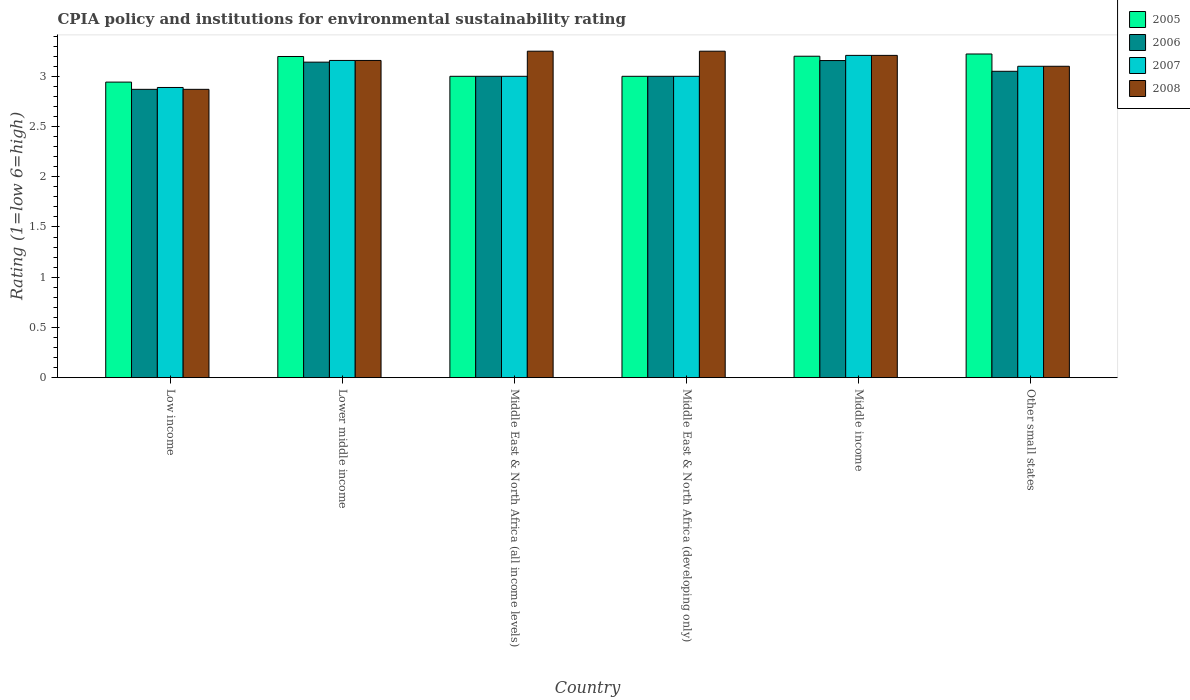Are the number of bars on each tick of the X-axis equal?
Make the answer very short. Yes. What is the label of the 4th group of bars from the left?
Ensure brevity in your answer.  Middle East & North Africa (developing only). What is the CPIA rating in 2006 in Middle income?
Keep it short and to the point. 3.16. Across all countries, what is the maximum CPIA rating in 2005?
Ensure brevity in your answer.  3.22. Across all countries, what is the minimum CPIA rating in 2007?
Offer a very short reply. 2.89. In which country was the CPIA rating in 2008 maximum?
Offer a very short reply. Middle East & North Africa (all income levels). In which country was the CPIA rating in 2006 minimum?
Give a very brief answer. Low income. What is the total CPIA rating in 2006 in the graph?
Ensure brevity in your answer.  18.22. What is the difference between the CPIA rating in 2006 in Lower middle income and that in Middle income?
Make the answer very short. -0.02. What is the difference between the CPIA rating in 2008 in Middle East & North Africa (developing only) and the CPIA rating in 2005 in Middle East & North Africa (all income levels)?
Offer a terse response. 0.25. What is the average CPIA rating in 2006 per country?
Your answer should be compact. 3.04. In how many countries, is the CPIA rating in 2007 greater than 1?
Give a very brief answer. 6. What is the ratio of the CPIA rating in 2006 in Middle East & North Africa (developing only) to that in Middle income?
Provide a short and direct response. 0.95. What is the difference between the highest and the second highest CPIA rating in 2008?
Ensure brevity in your answer.  -0.04. What is the difference between the highest and the lowest CPIA rating in 2005?
Make the answer very short. 0.28. In how many countries, is the CPIA rating in 2007 greater than the average CPIA rating in 2007 taken over all countries?
Offer a very short reply. 3. Is the sum of the CPIA rating in 2006 in Lower middle income and Middle income greater than the maximum CPIA rating in 2008 across all countries?
Offer a very short reply. Yes. What does the 1st bar from the left in Low income represents?
Offer a very short reply. 2005. How many bars are there?
Keep it short and to the point. 24. Are all the bars in the graph horizontal?
Your answer should be compact. No. How many countries are there in the graph?
Your answer should be compact. 6. What is the difference between two consecutive major ticks on the Y-axis?
Ensure brevity in your answer.  0.5. Does the graph contain grids?
Your response must be concise. No. What is the title of the graph?
Ensure brevity in your answer.  CPIA policy and institutions for environmental sustainability rating. What is the label or title of the Y-axis?
Make the answer very short. Rating (1=low 6=high). What is the Rating (1=low 6=high) of 2005 in Low income?
Provide a short and direct response. 2.94. What is the Rating (1=low 6=high) in 2006 in Low income?
Offer a very short reply. 2.87. What is the Rating (1=low 6=high) in 2007 in Low income?
Provide a succinct answer. 2.89. What is the Rating (1=low 6=high) of 2008 in Low income?
Provide a succinct answer. 2.87. What is the Rating (1=low 6=high) in 2005 in Lower middle income?
Your answer should be very brief. 3.2. What is the Rating (1=low 6=high) of 2006 in Lower middle income?
Your response must be concise. 3.14. What is the Rating (1=low 6=high) in 2007 in Lower middle income?
Make the answer very short. 3.16. What is the Rating (1=low 6=high) of 2008 in Lower middle income?
Your response must be concise. 3.16. What is the Rating (1=low 6=high) of 2007 in Middle East & North Africa (all income levels)?
Ensure brevity in your answer.  3. What is the Rating (1=low 6=high) in 2008 in Middle East & North Africa (all income levels)?
Provide a short and direct response. 3.25. What is the Rating (1=low 6=high) in 2005 in Middle East & North Africa (developing only)?
Offer a very short reply. 3. What is the Rating (1=low 6=high) in 2007 in Middle East & North Africa (developing only)?
Your response must be concise. 3. What is the Rating (1=low 6=high) in 2008 in Middle East & North Africa (developing only)?
Ensure brevity in your answer.  3.25. What is the Rating (1=low 6=high) of 2005 in Middle income?
Your answer should be very brief. 3.2. What is the Rating (1=low 6=high) in 2006 in Middle income?
Your response must be concise. 3.16. What is the Rating (1=low 6=high) in 2007 in Middle income?
Offer a very short reply. 3.21. What is the Rating (1=low 6=high) in 2008 in Middle income?
Provide a succinct answer. 3.21. What is the Rating (1=low 6=high) of 2005 in Other small states?
Make the answer very short. 3.22. What is the Rating (1=low 6=high) in 2006 in Other small states?
Make the answer very short. 3.05. What is the Rating (1=low 6=high) of 2008 in Other small states?
Make the answer very short. 3.1. Across all countries, what is the maximum Rating (1=low 6=high) of 2005?
Your response must be concise. 3.22. Across all countries, what is the maximum Rating (1=low 6=high) of 2006?
Your answer should be compact. 3.16. Across all countries, what is the maximum Rating (1=low 6=high) of 2007?
Your answer should be compact. 3.21. Across all countries, what is the maximum Rating (1=low 6=high) in 2008?
Provide a short and direct response. 3.25. Across all countries, what is the minimum Rating (1=low 6=high) in 2005?
Your answer should be very brief. 2.94. Across all countries, what is the minimum Rating (1=low 6=high) in 2006?
Your response must be concise. 2.87. Across all countries, what is the minimum Rating (1=low 6=high) in 2007?
Offer a very short reply. 2.89. Across all countries, what is the minimum Rating (1=low 6=high) in 2008?
Your response must be concise. 2.87. What is the total Rating (1=low 6=high) of 2005 in the graph?
Offer a terse response. 18.56. What is the total Rating (1=low 6=high) of 2006 in the graph?
Give a very brief answer. 18.22. What is the total Rating (1=low 6=high) in 2007 in the graph?
Keep it short and to the point. 18.36. What is the total Rating (1=low 6=high) of 2008 in the graph?
Your answer should be very brief. 18.84. What is the difference between the Rating (1=low 6=high) in 2005 in Low income and that in Lower middle income?
Your answer should be very brief. -0.26. What is the difference between the Rating (1=low 6=high) of 2006 in Low income and that in Lower middle income?
Keep it short and to the point. -0.27. What is the difference between the Rating (1=low 6=high) in 2007 in Low income and that in Lower middle income?
Offer a terse response. -0.27. What is the difference between the Rating (1=low 6=high) in 2008 in Low income and that in Lower middle income?
Your response must be concise. -0.29. What is the difference between the Rating (1=low 6=high) of 2005 in Low income and that in Middle East & North Africa (all income levels)?
Offer a very short reply. -0.06. What is the difference between the Rating (1=low 6=high) of 2006 in Low income and that in Middle East & North Africa (all income levels)?
Provide a short and direct response. -0.13. What is the difference between the Rating (1=low 6=high) of 2007 in Low income and that in Middle East & North Africa (all income levels)?
Offer a terse response. -0.11. What is the difference between the Rating (1=low 6=high) of 2008 in Low income and that in Middle East & North Africa (all income levels)?
Offer a very short reply. -0.38. What is the difference between the Rating (1=low 6=high) in 2005 in Low income and that in Middle East & North Africa (developing only)?
Ensure brevity in your answer.  -0.06. What is the difference between the Rating (1=low 6=high) in 2006 in Low income and that in Middle East & North Africa (developing only)?
Offer a very short reply. -0.13. What is the difference between the Rating (1=low 6=high) of 2007 in Low income and that in Middle East & North Africa (developing only)?
Offer a very short reply. -0.11. What is the difference between the Rating (1=low 6=high) of 2008 in Low income and that in Middle East & North Africa (developing only)?
Provide a short and direct response. -0.38. What is the difference between the Rating (1=low 6=high) in 2005 in Low income and that in Middle income?
Offer a very short reply. -0.26. What is the difference between the Rating (1=low 6=high) in 2006 in Low income and that in Middle income?
Offer a terse response. -0.29. What is the difference between the Rating (1=low 6=high) in 2007 in Low income and that in Middle income?
Offer a terse response. -0.32. What is the difference between the Rating (1=low 6=high) in 2008 in Low income and that in Middle income?
Offer a very short reply. -0.34. What is the difference between the Rating (1=low 6=high) in 2005 in Low income and that in Other small states?
Offer a very short reply. -0.28. What is the difference between the Rating (1=low 6=high) in 2006 in Low income and that in Other small states?
Give a very brief answer. -0.18. What is the difference between the Rating (1=low 6=high) of 2007 in Low income and that in Other small states?
Your answer should be compact. -0.21. What is the difference between the Rating (1=low 6=high) in 2008 in Low income and that in Other small states?
Your answer should be compact. -0.23. What is the difference between the Rating (1=low 6=high) in 2005 in Lower middle income and that in Middle East & North Africa (all income levels)?
Keep it short and to the point. 0.2. What is the difference between the Rating (1=low 6=high) in 2006 in Lower middle income and that in Middle East & North Africa (all income levels)?
Provide a short and direct response. 0.14. What is the difference between the Rating (1=low 6=high) in 2007 in Lower middle income and that in Middle East & North Africa (all income levels)?
Your answer should be very brief. 0.16. What is the difference between the Rating (1=low 6=high) in 2008 in Lower middle income and that in Middle East & North Africa (all income levels)?
Your answer should be very brief. -0.09. What is the difference between the Rating (1=low 6=high) of 2005 in Lower middle income and that in Middle East & North Africa (developing only)?
Your response must be concise. 0.2. What is the difference between the Rating (1=low 6=high) of 2006 in Lower middle income and that in Middle East & North Africa (developing only)?
Give a very brief answer. 0.14. What is the difference between the Rating (1=low 6=high) of 2007 in Lower middle income and that in Middle East & North Africa (developing only)?
Offer a terse response. 0.16. What is the difference between the Rating (1=low 6=high) of 2008 in Lower middle income and that in Middle East & North Africa (developing only)?
Offer a very short reply. -0.09. What is the difference between the Rating (1=low 6=high) of 2005 in Lower middle income and that in Middle income?
Offer a terse response. -0. What is the difference between the Rating (1=low 6=high) of 2006 in Lower middle income and that in Middle income?
Offer a terse response. -0.02. What is the difference between the Rating (1=low 6=high) in 2007 in Lower middle income and that in Middle income?
Provide a short and direct response. -0.05. What is the difference between the Rating (1=low 6=high) of 2008 in Lower middle income and that in Middle income?
Make the answer very short. -0.05. What is the difference between the Rating (1=low 6=high) of 2005 in Lower middle income and that in Other small states?
Provide a short and direct response. -0.02. What is the difference between the Rating (1=low 6=high) of 2006 in Lower middle income and that in Other small states?
Make the answer very short. 0.09. What is the difference between the Rating (1=low 6=high) of 2007 in Lower middle income and that in Other small states?
Give a very brief answer. 0.06. What is the difference between the Rating (1=low 6=high) of 2008 in Lower middle income and that in Other small states?
Give a very brief answer. 0.06. What is the difference between the Rating (1=low 6=high) in 2005 in Middle East & North Africa (all income levels) and that in Middle East & North Africa (developing only)?
Offer a very short reply. 0. What is the difference between the Rating (1=low 6=high) in 2005 in Middle East & North Africa (all income levels) and that in Middle income?
Your answer should be compact. -0.2. What is the difference between the Rating (1=low 6=high) in 2006 in Middle East & North Africa (all income levels) and that in Middle income?
Provide a succinct answer. -0.16. What is the difference between the Rating (1=low 6=high) of 2007 in Middle East & North Africa (all income levels) and that in Middle income?
Your answer should be compact. -0.21. What is the difference between the Rating (1=low 6=high) in 2008 in Middle East & North Africa (all income levels) and that in Middle income?
Make the answer very short. 0.04. What is the difference between the Rating (1=low 6=high) in 2005 in Middle East & North Africa (all income levels) and that in Other small states?
Ensure brevity in your answer.  -0.22. What is the difference between the Rating (1=low 6=high) of 2007 in Middle East & North Africa (all income levels) and that in Other small states?
Make the answer very short. -0.1. What is the difference between the Rating (1=low 6=high) of 2006 in Middle East & North Africa (developing only) and that in Middle income?
Provide a succinct answer. -0.16. What is the difference between the Rating (1=low 6=high) of 2007 in Middle East & North Africa (developing only) and that in Middle income?
Offer a very short reply. -0.21. What is the difference between the Rating (1=low 6=high) of 2008 in Middle East & North Africa (developing only) and that in Middle income?
Provide a short and direct response. 0.04. What is the difference between the Rating (1=low 6=high) in 2005 in Middle East & North Africa (developing only) and that in Other small states?
Your answer should be very brief. -0.22. What is the difference between the Rating (1=low 6=high) of 2007 in Middle East & North Africa (developing only) and that in Other small states?
Offer a terse response. -0.1. What is the difference between the Rating (1=low 6=high) in 2008 in Middle East & North Africa (developing only) and that in Other small states?
Your answer should be very brief. 0.15. What is the difference between the Rating (1=low 6=high) in 2005 in Middle income and that in Other small states?
Ensure brevity in your answer.  -0.02. What is the difference between the Rating (1=low 6=high) of 2006 in Middle income and that in Other small states?
Ensure brevity in your answer.  0.11. What is the difference between the Rating (1=low 6=high) of 2007 in Middle income and that in Other small states?
Make the answer very short. 0.11. What is the difference between the Rating (1=low 6=high) in 2008 in Middle income and that in Other small states?
Keep it short and to the point. 0.11. What is the difference between the Rating (1=low 6=high) in 2005 in Low income and the Rating (1=low 6=high) in 2006 in Lower middle income?
Give a very brief answer. -0.2. What is the difference between the Rating (1=low 6=high) in 2005 in Low income and the Rating (1=low 6=high) in 2007 in Lower middle income?
Give a very brief answer. -0.22. What is the difference between the Rating (1=low 6=high) of 2005 in Low income and the Rating (1=low 6=high) of 2008 in Lower middle income?
Your response must be concise. -0.22. What is the difference between the Rating (1=low 6=high) of 2006 in Low income and the Rating (1=low 6=high) of 2007 in Lower middle income?
Make the answer very short. -0.29. What is the difference between the Rating (1=low 6=high) of 2006 in Low income and the Rating (1=low 6=high) of 2008 in Lower middle income?
Make the answer very short. -0.29. What is the difference between the Rating (1=low 6=high) in 2007 in Low income and the Rating (1=low 6=high) in 2008 in Lower middle income?
Offer a terse response. -0.27. What is the difference between the Rating (1=low 6=high) of 2005 in Low income and the Rating (1=low 6=high) of 2006 in Middle East & North Africa (all income levels)?
Offer a terse response. -0.06. What is the difference between the Rating (1=low 6=high) in 2005 in Low income and the Rating (1=low 6=high) in 2007 in Middle East & North Africa (all income levels)?
Your answer should be very brief. -0.06. What is the difference between the Rating (1=low 6=high) of 2005 in Low income and the Rating (1=low 6=high) of 2008 in Middle East & North Africa (all income levels)?
Make the answer very short. -0.31. What is the difference between the Rating (1=low 6=high) in 2006 in Low income and the Rating (1=low 6=high) in 2007 in Middle East & North Africa (all income levels)?
Provide a succinct answer. -0.13. What is the difference between the Rating (1=low 6=high) of 2006 in Low income and the Rating (1=low 6=high) of 2008 in Middle East & North Africa (all income levels)?
Your response must be concise. -0.38. What is the difference between the Rating (1=low 6=high) of 2007 in Low income and the Rating (1=low 6=high) of 2008 in Middle East & North Africa (all income levels)?
Offer a terse response. -0.36. What is the difference between the Rating (1=low 6=high) in 2005 in Low income and the Rating (1=low 6=high) in 2006 in Middle East & North Africa (developing only)?
Give a very brief answer. -0.06. What is the difference between the Rating (1=low 6=high) of 2005 in Low income and the Rating (1=low 6=high) of 2007 in Middle East & North Africa (developing only)?
Provide a succinct answer. -0.06. What is the difference between the Rating (1=low 6=high) in 2005 in Low income and the Rating (1=low 6=high) in 2008 in Middle East & North Africa (developing only)?
Keep it short and to the point. -0.31. What is the difference between the Rating (1=low 6=high) in 2006 in Low income and the Rating (1=low 6=high) in 2007 in Middle East & North Africa (developing only)?
Ensure brevity in your answer.  -0.13. What is the difference between the Rating (1=low 6=high) in 2006 in Low income and the Rating (1=low 6=high) in 2008 in Middle East & North Africa (developing only)?
Provide a succinct answer. -0.38. What is the difference between the Rating (1=low 6=high) of 2007 in Low income and the Rating (1=low 6=high) of 2008 in Middle East & North Africa (developing only)?
Provide a short and direct response. -0.36. What is the difference between the Rating (1=low 6=high) in 2005 in Low income and the Rating (1=low 6=high) in 2006 in Middle income?
Offer a very short reply. -0.21. What is the difference between the Rating (1=low 6=high) in 2005 in Low income and the Rating (1=low 6=high) in 2007 in Middle income?
Your answer should be compact. -0.27. What is the difference between the Rating (1=low 6=high) of 2005 in Low income and the Rating (1=low 6=high) of 2008 in Middle income?
Offer a terse response. -0.27. What is the difference between the Rating (1=low 6=high) of 2006 in Low income and the Rating (1=low 6=high) of 2007 in Middle income?
Provide a succinct answer. -0.34. What is the difference between the Rating (1=low 6=high) in 2006 in Low income and the Rating (1=low 6=high) in 2008 in Middle income?
Your answer should be very brief. -0.34. What is the difference between the Rating (1=low 6=high) in 2007 in Low income and the Rating (1=low 6=high) in 2008 in Middle income?
Your answer should be compact. -0.32. What is the difference between the Rating (1=low 6=high) of 2005 in Low income and the Rating (1=low 6=high) of 2006 in Other small states?
Provide a short and direct response. -0.11. What is the difference between the Rating (1=low 6=high) in 2005 in Low income and the Rating (1=low 6=high) in 2007 in Other small states?
Ensure brevity in your answer.  -0.16. What is the difference between the Rating (1=low 6=high) of 2005 in Low income and the Rating (1=low 6=high) of 2008 in Other small states?
Your response must be concise. -0.16. What is the difference between the Rating (1=low 6=high) of 2006 in Low income and the Rating (1=low 6=high) of 2007 in Other small states?
Keep it short and to the point. -0.23. What is the difference between the Rating (1=low 6=high) of 2006 in Low income and the Rating (1=low 6=high) of 2008 in Other small states?
Provide a short and direct response. -0.23. What is the difference between the Rating (1=low 6=high) of 2007 in Low income and the Rating (1=low 6=high) of 2008 in Other small states?
Make the answer very short. -0.21. What is the difference between the Rating (1=low 6=high) of 2005 in Lower middle income and the Rating (1=low 6=high) of 2006 in Middle East & North Africa (all income levels)?
Keep it short and to the point. 0.2. What is the difference between the Rating (1=low 6=high) of 2005 in Lower middle income and the Rating (1=low 6=high) of 2007 in Middle East & North Africa (all income levels)?
Keep it short and to the point. 0.2. What is the difference between the Rating (1=low 6=high) of 2005 in Lower middle income and the Rating (1=low 6=high) of 2008 in Middle East & North Africa (all income levels)?
Provide a succinct answer. -0.05. What is the difference between the Rating (1=low 6=high) in 2006 in Lower middle income and the Rating (1=low 6=high) in 2007 in Middle East & North Africa (all income levels)?
Your response must be concise. 0.14. What is the difference between the Rating (1=low 6=high) of 2006 in Lower middle income and the Rating (1=low 6=high) of 2008 in Middle East & North Africa (all income levels)?
Offer a terse response. -0.11. What is the difference between the Rating (1=low 6=high) in 2007 in Lower middle income and the Rating (1=low 6=high) in 2008 in Middle East & North Africa (all income levels)?
Offer a terse response. -0.09. What is the difference between the Rating (1=low 6=high) of 2005 in Lower middle income and the Rating (1=low 6=high) of 2006 in Middle East & North Africa (developing only)?
Give a very brief answer. 0.2. What is the difference between the Rating (1=low 6=high) in 2005 in Lower middle income and the Rating (1=low 6=high) in 2007 in Middle East & North Africa (developing only)?
Ensure brevity in your answer.  0.2. What is the difference between the Rating (1=low 6=high) of 2005 in Lower middle income and the Rating (1=low 6=high) of 2008 in Middle East & North Africa (developing only)?
Offer a terse response. -0.05. What is the difference between the Rating (1=low 6=high) in 2006 in Lower middle income and the Rating (1=low 6=high) in 2007 in Middle East & North Africa (developing only)?
Keep it short and to the point. 0.14. What is the difference between the Rating (1=low 6=high) in 2006 in Lower middle income and the Rating (1=low 6=high) in 2008 in Middle East & North Africa (developing only)?
Your answer should be compact. -0.11. What is the difference between the Rating (1=low 6=high) of 2007 in Lower middle income and the Rating (1=low 6=high) of 2008 in Middle East & North Africa (developing only)?
Offer a very short reply. -0.09. What is the difference between the Rating (1=low 6=high) of 2005 in Lower middle income and the Rating (1=low 6=high) of 2006 in Middle income?
Ensure brevity in your answer.  0.04. What is the difference between the Rating (1=low 6=high) of 2005 in Lower middle income and the Rating (1=low 6=high) of 2007 in Middle income?
Offer a very short reply. -0.01. What is the difference between the Rating (1=low 6=high) of 2005 in Lower middle income and the Rating (1=low 6=high) of 2008 in Middle income?
Your answer should be compact. -0.01. What is the difference between the Rating (1=low 6=high) in 2006 in Lower middle income and the Rating (1=low 6=high) in 2007 in Middle income?
Ensure brevity in your answer.  -0.07. What is the difference between the Rating (1=low 6=high) of 2006 in Lower middle income and the Rating (1=low 6=high) of 2008 in Middle income?
Your response must be concise. -0.07. What is the difference between the Rating (1=low 6=high) in 2007 in Lower middle income and the Rating (1=low 6=high) in 2008 in Middle income?
Make the answer very short. -0.05. What is the difference between the Rating (1=low 6=high) of 2005 in Lower middle income and the Rating (1=low 6=high) of 2006 in Other small states?
Your answer should be very brief. 0.15. What is the difference between the Rating (1=low 6=high) of 2005 in Lower middle income and the Rating (1=low 6=high) of 2007 in Other small states?
Provide a short and direct response. 0.1. What is the difference between the Rating (1=low 6=high) of 2005 in Lower middle income and the Rating (1=low 6=high) of 2008 in Other small states?
Make the answer very short. 0.1. What is the difference between the Rating (1=low 6=high) in 2006 in Lower middle income and the Rating (1=low 6=high) in 2007 in Other small states?
Make the answer very short. 0.04. What is the difference between the Rating (1=low 6=high) in 2006 in Lower middle income and the Rating (1=low 6=high) in 2008 in Other small states?
Keep it short and to the point. 0.04. What is the difference between the Rating (1=low 6=high) in 2007 in Lower middle income and the Rating (1=low 6=high) in 2008 in Other small states?
Your answer should be compact. 0.06. What is the difference between the Rating (1=low 6=high) in 2005 in Middle East & North Africa (all income levels) and the Rating (1=low 6=high) in 2006 in Middle East & North Africa (developing only)?
Ensure brevity in your answer.  0. What is the difference between the Rating (1=low 6=high) of 2005 in Middle East & North Africa (all income levels) and the Rating (1=low 6=high) of 2007 in Middle East & North Africa (developing only)?
Keep it short and to the point. 0. What is the difference between the Rating (1=low 6=high) in 2006 in Middle East & North Africa (all income levels) and the Rating (1=low 6=high) in 2007 in Middle East & North Africa (developing only)?
Offer a very short reply. 0. What is the difference between the Rating (1=low 6=high) in 2007 in Middle East & North Africa (all income levels) and the Rating (1=low 6=high) in 2008 in Middle East & North Africa (developing only)?
Your answer should be compact. -0.25. What is the difference between the Rating (1=low 6=high) of 2005 in Middle East & North Africa (all income levels) and the Rating (1=low 6=high) of 2006 in Middle income?
Make the answer very short. -0.16. What is the difference between the Rating (1=low 6=high) of 2005 in Middle East & North Africa (all income levels) and the Rating (1=low 6=high) of 2007 in Middle income?
Make the answer very short. -0.21. What is the difference between the Rating (1=low 6=high) of 2005 in Middle East & North Africa (all income levels) and the Rating (1=low 6=high) of 2008 in Middle income?
Offer a very short reply. -0.21. What is the difference between the Rating (1=low 6=high) in 2006 in Middle East & North Africa (all income levels) and the Rating (1=low 6=high) in 2007 in Middle income?
Your answer should be compact. -0.21. What is the difference between the Rating (1=low 6=high) in 2006 in Middle East & North Africa (all income levels) and the Rating (1=low 6=high) in 2008 in Middle income?
Offer a very short reply. -0.21. What is the difference between the Rating (1=low 6=high) of 2007 in Middle East & North Africa (all income levels) and the Rating (1=low 6=high) of 2008 in Middle income?
Offer a very short reply. -0.21. What is the difference between the Rating (1=low 6=high) of 2005 in Middle East & North Africa (all income levels) and the Rating (1=low 6=high) of 2007 in Other small states?
Your answer should be very brief. -0.1. What is the difference between the Rating (1=low 6=high) in 2006 in Middle East & North Africa (all income levels) and the Rating (1=low 6=high) in 2008 in Other small states?
Provide a succinct answer. -0.1. What is the difference between the Rating (1=low 6=high) in 2005 in Middle East & North Africa (developing only) and the Rating (1=low 6=high) in 2006 in Middle income?
Your answer should be compact. -0.16. What is the difference between the Rating (1=low 6=high) of 2005 in Middle East & North Africa (developing only) and the Rating (1=low 6=high) of 2007 in Middle income?
Ensure brevity in your answer.  -0.21. What is the difference between the Rating (1=low 6=high) of 2005 in Middle East & North Africa (developing only) and the Rating (1=low 6=high) of 2008 in Middle income?
Give a very brief answer. -0.21. What is the difference between the Rating (1=low 6=high) of 2006 in Middle East & North Africa (developing only) and the Rating (1=low 6=high) of 2007 in Middle income?
Give a very brief answer. -0.21. What is the difference between the Rating (1=low 6=high) of 2006 in Middle East & North Africa (developing only) and the Rating (1=low 6=high) of 2008 in Middle income?
Give a very brief answer. -0.21. What is the difference between the Rating (1=low 6=high) of 2007 in Middle East & North Africa (developing only) and the Rating (1=low 6=high) of 2008 in Middle income?
Provide a short and direct response. -0.21. What is the difference between the Rating (1=low 6=high) in 2005 in Middle East & North Africa (developing only) and the Rating (1=low 6=high) in 2006 in Other small states?
Keep it short and to the point. -0.05. What is the difference between the Rating (1=low 6=high) of 2005 in Middle East & North Africa (developing only) and the Rating (1=low 6=high) of 2008 in Other small states?
Ensure brevity in your answer.  -0.1. What is the difference between the Rating (1=low 6=high) in 2006 in Middle East & North Africa (developing only) and the Rating (1=low 6=high) in 2007 in Other small states?
Keep it short and to the point. -0.1. What is the difference between the Rating (1=low 6=high) in 2006 in Middle East & North Africa (developing only) and the Rating (1=low 6=high) in 2008 in Other small states?
Your response must be concise. -0.1. What is the difference between the Rating (1=low 6=high) in 2007 in Middle East & North Africa (developing only) and the Rating (1=low 6=high) in 2008 in Other small states?
Provide a succinct answer. -0.1. What is the difference between the Rating (1=low 6=high) in 2005 in Middle income and the Rating (1=low 6=high) in 2006 in Other small states?
Your answer should be compact. 0.15. What is the difference between the Rating (1=low 6=high) in 2005 in Middle income and the Rating (1=low 6=high) in 2008 in Other small states?
Ensure brevity in your answer.  0.1. What is the difference between the Rating (1=low 6=high) of 2006 in Middle income and the Rating (1=low 6=high) of 2007 in Other small states?
Provide a short and direct response. 0.06. What is the difference between the Rating (1=low 6=high) of 2006 in Middle income and the Rating (1=low 6=high) of 2008 in Other small states?
Your answer should be compact. 0.06. What is the difference between the Rating (1=low 6=high) of 2007 in Middle income and the Rating (1=low 6=high) of 2008 in Other small states?
Offer a very short reply. 0.11. What is the average Rating (1=low 6=high) of 2005 per country?
Offer a very short reply. 3.09. What is the average Rating (1=low 6=high) of 2006 per country?
Offer a terse response. 3.04. What is the average Rating (1=low 6=high) of 2007 per country?
Offer a terse response. 3.06. What is the average Rating (1=low 6=high) in 2008 per country?
Provide a succinct answer. 3.14. What is the difference between the Rating (1=low 6=high) of 2005 and Rating (1=low 6=high) of 2006 in Low income?
Your answer should be very brief. 0.07. What is the difference between the Rating (1=low 6=high) in 2005 and Rating (1=low 6=high) in 2007 in Low income?
Ensure brevity in your answer.  0.05. What is the difference between the Rating (1=low 6=high) of 2005 and Rating (1=low 6=high) of 2008 in Low income?
Give a very brief answer. 0.07. What is the difference between the Rating (1=low 6=high) in 2006 and Rating (1=low 6=high) in 2007 in Low income?
Your answer should be compact. -0.02. What is the difference between the Rating (1=low 6=high) in 2006 and Rating (1=low 6=high) in 2008 in Low income?
Offer a terse response. 0. What is the difference between the Rating (1=low 6=high) in 2007 and Rating (1=low 6=high) in 2008 in Low income?
Your answer should be very brief. 0.02. What is the difference between the Rating (1=low 6=high) of 2005 and Rating (1=low 6=high) of 2006 in Lower middle income?
Offer a terse response. 0.06. What is the difference between the Rating (1=low 6=high) in 2005 and Rating (1=low 6=high) in 2007 in Lower middle income?
Give a very brief answer. 0.04. What is the difference between the Rating (1=low 6=high) in 2005 and Rating (1=low 6=high) in 2008 in Lower middle income?
Give a very brief answer. 0.04. What is the difference between the Rating (1=low 6=high) in 2006 and Rating (1=low 6=high) in 2007 in Lower middle income?
Make the answer very short. -0.02. What is the difference between the Rating (1=low 6=high) of 2006 and Rating (1=low 6=high) of 2008 in Lower middle income?
Your answer should be very brief. -0.02. What is the difference between the Rating (1=low 6=high) of 2005 and Rating (1=low 6=high) of 2007 in Middle East & North Africa (all income levels)?
Your answer should be very brief. 0. What is the difference between the Rating (1=low 6=high) in 2006 and Rating (1=low 6=high) in 2007 in Middle East & North Africa (all income levels)?
Keep it short and to the point. 0. What is the difference between the Rating (1=low 6=high) of 2006 and Rating (1=low 6=high) of 2008 in Middle East & North Africa (all income levels)?
Provide a short and direct response. -0.25. What is the difference between the Rating (1=low 6=high) of 2005 and Rating (1=low 6=high) of 2006 in Middle East & North Africa (developing only)?
Give a very brief answer. 0. What is the difference between the Rating (1=low 6=high) of 2005 and Rating (1=low 6=high) of 2008 in Middle East & North Africa (developing only)?
Give a very brief answer. -0.25. What is the difference between the Rating (1=low 6=high) of 2006 and Rating (1=low 6=high) of 2007 in Middle East & North Africa (developing only)?
Your response must be concise. 0. What is the difference between the Rating (1=low 6=high) in 2006 and Rating (1=low 6=high) in 2008 in Middle East & North Africa (developing only)?
Ensure brevity in your answer.  -0.25. What is the difference between the Rating (1=low 6=high) of 2007 and Rating (1=low 6=high) of 2008 in Middle East & North Africa (developing only)?
Ensure brevity in your answer.  -0.25. What is the difference between the Rating (1=low 6=high) in 2005 and Rating (1=low 6=high) in 2006 in Middle income?
Provide a short and direct response. 0.04. What is the difference between the Rating (1=low 6=high) of 2005 and Rating (1=low 6=high) of 2007 in Middle income?
Ensure brevity in your answer.  -0.01. What is the difference between the Rating (1=low 6=high) in 2005 and Rating (1=low 6=high) in 2008 in Middle income?
Your answer should be very brief. -0.01. What is the difference between the Rating (1=low 6=high) in 2006 and Rating (1=low 6=high) in 2007 in Middle income?
Make the answer very short. -0.05. What is the difference between the Rating (1=low 6=high) of 2006 and Rating (1=low 6=high) of 2008 in Middle income?
Offer a very short reply. -0.05. What is the difference between the Rating (1=low 6=high) in 2007 and Rating (1=low 6=high) in 2008 in Middle income?
Your answer should be very brief. 0. What is the difference between the Rating (1=low 6=high) of 2005 and Rating (1=low 6=high) of 2006 in Other small states?
Give a very brief answer. 0.17. What is the difference between the Rating (1=low 6=high) in 2005 and Rating (1=low 6=high) in 2007 in Other small states?
Your response must be concise. 0.12. What is the difference between the Rating (1=low 6=high) in 2005 and Rating (1=low 6=high) in 2008 in Other small states?
Offer a very short reply. 0.12. What is the difference between the Rating (1=low 6=high) in 2006 and Rating (1=low 6=high) in 2007 in Other small states?
Keep it short and to the point. -0.05. What is the ratio of the Rating (1=low 6=high) in 2005 in Low income to that in Lower middle income?
Your response must be concise. 0.92. What is the ratio of the Rating (1=low 6=high) of 2006 in Low income to that in Lower middle income?
Ensure brevity in your answer.  0.91. What is the ratio of the Rating (1=low 6=high) in 2007 in Low income to that in Lower middle income?
Give a very brief answer. 0.91. What is the ratio of the Rating (1=low 6=high) in 2008 in Low income to that in Lower middle income?
Your response must be concise. 0.91. What is the ratio of the Rating (1=low 6=high) in 2005 in Low income to that in Middle East & North Africa (all income levels)?
Your answer should be very brief. 0.98. What is the ratio of the Rating (1=low 6=high) in 2006 in Low income to that in Middle East & North Africa (all income levels)?
Offer a very short reply. 0.96. What is the ratio of the Rating (1=low 6=high) in 2008 in Low income to that in Middle East & North Africa (all income levels)?
Your response must be concise. 0.88. What is the ratio of the Rating (1=low 6=high) of 2005 in Low income to that in Middle East & North Africa (developing only)?
Provide a short and direct response. 0.98. What is the ratio of the Rating (1=low 6=high) in 2006 in Low income to that in Middle East & North Africa (developing only)?
Give a very brief answer. 0.96. What is the ratio of the Rating (1=low 6=high) in 2007 in Low income to that in Middle East & North Africa (developing only)?
Offer a very short reply. 0.96. What is the ratio of the Rating (1=low 6=high) of 2008 in Low income to that in Middle East & North Africa (developing only)?
Keep it short and to the point. 0.88. What is the ratio of the Rating (1=low 6=high) of 2005 in Low income to that in Middle income?
Your answer should be very brief. 0.92. What is the ratio of the Rating (1=low 6=high) in 2006 in Low income to that in Middle income?
Offer a very short reply. 0.91. What is the ratio of the Rating (1=low 6=high) of 2007 in Low income to that in Middle income?
Ensure brevity in your answer.  0.9. What is the ratio of the Rating (1=low 6=high) of 2008 in Low income to that in Middle income?
Your answer should be compact. 0.89. What is the ratio of the Rating (1=low 6=high) in 2005 in Low income to that in Other small states?
Give a very brief answer. 0.91. What is the ratio of the Rating (1=low 6=high) in 2006 in Low income to that in Other small states?
Offer a very short reply. 0.94. What is the ratio of the Rating (1=low 6=high) of 2007 in Low income to that in Other small states?
Provide a succinct answer. 0.93. What is the ratio of the Rating (1=low 6=high) of 2008 in Low income to that in Other small states?
Offer a terse response. 0.93. What is the ratio of the Rating (1=low 6=high) in 2005 in Lower middle income to that in Middle East & North Africa (all income levels)?
Ensure brevity in your answer.  1.07. What is the ratio of the Rating (1=low 6=high) of 2006 in Lower middle income to that in Middle East & North Africa (all income levels)?
Keep it short and to the point. 1.05. What is the ratio of the Rating (1=low 6=high) in 2007 in Lower middle income to that in Middle East & North Africa (all income levels)?
Give a very brief answer. 1.05. What is the ratio of the Rating (1=low 6=high) of 2008 in Lower middle income to that in Middle East & North Africa (all income levels)?
Offer a very short reply. 0.97. What is the ratio of the Rating (1=low 6=high) of 2005 in Lower middle income to that in Middle East & North Africa (developing only)?
Make the answer very short. 1.07. What is the ratio of the Rating (1=low 6=high) in 2006 in Lower middle income to that in Middle East & North Africa (developing only)?
Offer a very short reply. 1.05. What is the ratio of the Rating (1=low 6=high) of 2007 in Lower middle income to that in Middle East & North Africa (developing only)?
Keep it short and to the point. 1.05. What is the ratio of the Rating (1=low 6=high) in 2008 in Lower middle income to that in Middle East & North Africa (developing only)?
Give a very brief answer. 0.97. What is the ratio of the Rating (1=low 6=high) in 2005 in Lower middle income to that in Middle income?
Offer a terse response. 1. What is the ratio of the Rating (1=low 6=high) in 2007 in Lower middle income to that in Middle income?
Provide a short and direct response. 0.98. What is the ratio of the Rating (1=low 6=high) in 2008 in Lower middle income to that in Middle income?
Keep it short and to the point. 0.98. What is the ratio of the Rating (1=low 6=high) in 2006 in Lower middle income to that in Other small states?
Your answer should be very brief. 1.03. What is the ratio of the Rating (1=low 6=high) in 2007 in Lower middle income to that in Other small states?
Make the answer very short. 1.02. What is the ratio of the Rating (1=low 6=high) in 2008 in Lower middle income to that in Other small states?
Your answer should be compact. 1.02. What is the ratio of the Rating (1=low 6=high) of 2005 in Middle East & North Africa (all income levels) to that in Middle East & North Africa (developing only)?
Ensure brevity in your answer.  1. What is the ratio of the Rating (1=low 6=high) in 2007 in Middle East & North Africa (all income levels) to that in Middle East & North Africa (developing only)?
Provide a short and direct response. 1. What is the ratio of the Rating (1=low 6=high) in 2006 in Middle East & North Africa (all income levels) to that in Middle income?
Make the answer very short. 0.95. What is the ratio of the Rating (1=low 6=high) in 2007 in Middle East & North Africa (all income levels) to that in Middle income?
Keep it short and to the point. 0.94. What is the ratio of the Rating (1=low 6=high) of 2005 in Middle East & North Africa (all income levels) to that in Other small states?
Provide a succinct answer. 0.93. What is the ratio of the Rating (1=low 6=high) in 2006 in Middle East & North Africa (all income levels) to that in Other small states?
Your answer should be very brief. 0.98. What is the ratio of the Rating (1=low 6=high) of 2007 in Middle East & North Africa (all income levels) to that in Other small states?
Provide a short and direct response. 0.97. What is the ratio of the Rating (1=low 6=high) in 2008 in Middle East & North Africa (all income levels) to that in Other small states?
Offer a very short reply. 1.05. What is the ratio of the Rating (1=low 6=high) of 2005 in Middle East & North Africa (developing only) to that in Middle income?
Your response must be concise. 0.94. What is the ratio of the Rating (1=low 6=high) of 2006 in Middle East & North Africa (developing only) to that in Middle income?
Your response must be concise. 0.95. What is the ratio of the Rating (1=low 6=high) of 2007 in Middle East & North Africa (developing only) to that in Middle income?
Keep it short and to the point. 0.94. What is the ratio of the Rating (1=low 6=high) of 2006 in Middle East & North Africa (developing only) to that in Other small states?
Your answer should be compact. 0.98. What is the ratio of the Rating (1=low 6=high) of 2008 in Middle East & North Africa (developing only) to that in Other small states?
Make the answer very short. 1.05. What is the ratio of the Rating (1=low 6=high) of 2005 in Middle income to that in Other small states?
Your response must be concise. 0.99. What is the ratio of the Rating (1=low 6=high) in 2006 in Middle income to that in Other small states?
Make the answer very short. 1.03. What is the ratio of the Rating (1=low 6=high) of 2007 in Middle income to that in Other small states?
Offer a very short reply. 1.03. What is the ratio of the Rating (1=low 6=high) of 2008 in Middle income to that in Other small states?
Offer a terse response. 1.03. What is the difference between the highest and the second highest Rating (1=low 6=high) in 2005?
Make the answer very short. 0.02. What is the difference between the highest and the second highest Rating (1=low 6=high) in 2006?
Provide a short and direct response. 0.02. What is the difference between the highest and the second highest Rating (1=low 6=high) in 2007?
Your response must be concise. 0.05. What is the difference between the highest and the lowest Rating (1=low 6=high) of 2005?
Your response must be concise. 0.28. What is the difference between the highest and the lowest Rating (1=low 6=high) in 2006?
Offer a terse response. 0.29. What is the difference between the highest and the lowest Rating (1=low 6=high) of 2007?
Make the answer very short. 0.32. What is the difference between the highest and the lowest Rating (1=low 6=high) in 2008?
Offer a very short reply. 0.38. 